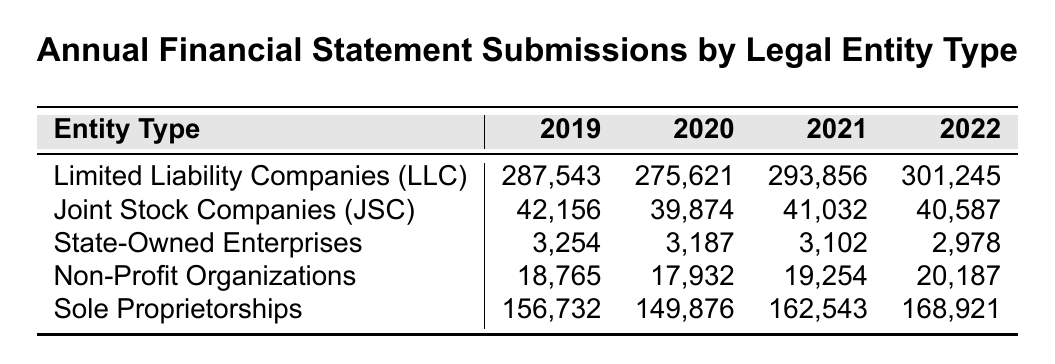What was the number of annual financial statement submissions for Limited Liability Companies (LLC) in 2021? The table shows that in 2021, Limited Liability Companies (LLC) had 293,856 submissions listed under that year.
Answer: 293,856 Which legal entity type had the highest number of submissions in 2022? According to the table, Limited Liability Companies (LLC) had the highest number of submissions in 2022 with 301,245.
Answer: Limited Liability Companies (LLC) How many submissions did State-Owned Enterprises report in 2019? The corresponding row for State-Owned Enterprises shows that there were 3,254 submissions in 2019.
Answer: 3,254 What is the total number of submissions made by Sole Proprietorships from 2019 to 2022? By adding the values for Sole Proprietorships from 2019 to 2022: 156,732 + 149,876 + 162,543 + 168,921 = 638,072.
Answer: 638,072 Did Joint Stock Companies (JSC) have more submissions in 2021 than in 2020? The table indicates that Joint Stock Companies (JSC) had 41,032 submissions in 2021 and 39,874 in 2020, meaning they did have more in 2021.
Answer: Yes What was the percentage increase in submissions for Non-Profit Organizations from 2019 to 2022? The values for Non-Profit Organizations are 18,765 in 2019 and 20,187 in 2022. The increase is calculated as ((20,187 - 18,765) / 18,765) * 100 ≈ 7.57%, identifying a percentage increase.
Answer: Approximately 7.57% Which entity type had a decrease in submissions every year from 2019 to 2022? Analyzing the submissions for State-Owned Enterprises reveals decreases each year: 3,254 in 2019 to 2,978 in 2022, indicating consistent decline.
Answer: State-Owned Enterprises What is the average number of submissions for Joint Stock Companies (JSC) over the years? To find the average, sum the submissions: 42,156 + 39,874 + 41,032 + 40,587 = 163,649. Then divide by 4 (the number of years): 163,649 / 4 = 40,912.25. This provides the average number of submissions.
Answer: 40,912.25 Is the number of submissions for Sole Proprietorships higher in 2022 than in 2021? In the table, Sole Proprietorships had 168,921 in 2022 and 162,543 in 2021, confirming that the 2022 numbers are indeed higher.
Answer: Yes What was the total increase in submissions for Limited Liability Companies (LLC) from 2019 to 2022? The submissions for Limited Liability Companies (LLC) increased from 287,543 in 2019 to 301,245 in 2022. The increase is calculated as 301,245 - 287,543 = 13,702, indicating the total increase over the years.
Answer: 13,702 